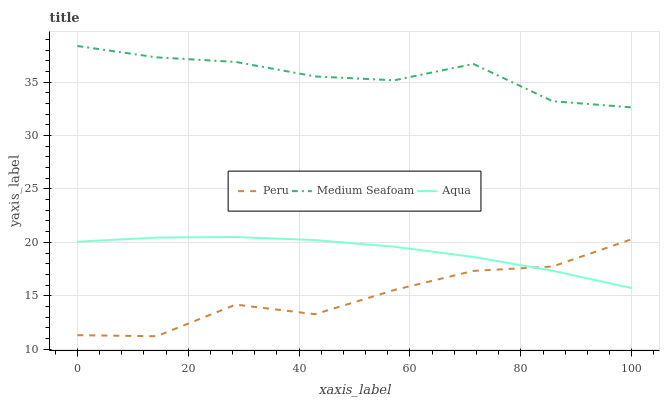Does Peru have the minimum area under the curve?
Answer yes or no. Yes. Does Medium Seafoam have the maximum area under the curve?
Answer yes or no. Yes. Does Medium Seafoam have the minimum area under the curve?
Answer yes or no. No. Does Peru have the maximum area under the curve?
Answer yes or no. No. Is Aqua the smoothest?
Answer yes or no. Yes. Is Peru the roughest?
Answer yes or no. Yes. Is Medium Seafoam the smoothest?
Answer yes or no. No. Is Medium Seafoam the roughest?
Answer yes or no. No. Does Peru have the lowest value?
Answer yes or no. Yes. Does Medium Seafoam have the lowest value?
Answer yes or no. No. Does Medium Seafoam have the highest value?
Answer yes or no. Yes. Does Peru have the highest value?
Answer yes or no. No. Is Peru less than Medium Seafoam?
Answer yes or no. Yes. Is Medium Seafoam greater than Peru?
Answer yes or no. Yes. Does Peru intersect Aqua?
Answer yes or no. Yes. Is Peru less than Aqua?
Answer yes or no. No. Is Peru greater than Aqua?
Answer yes or no. No. Does Peru intersect Medium Seafoam?
Answer yes or no. No. 